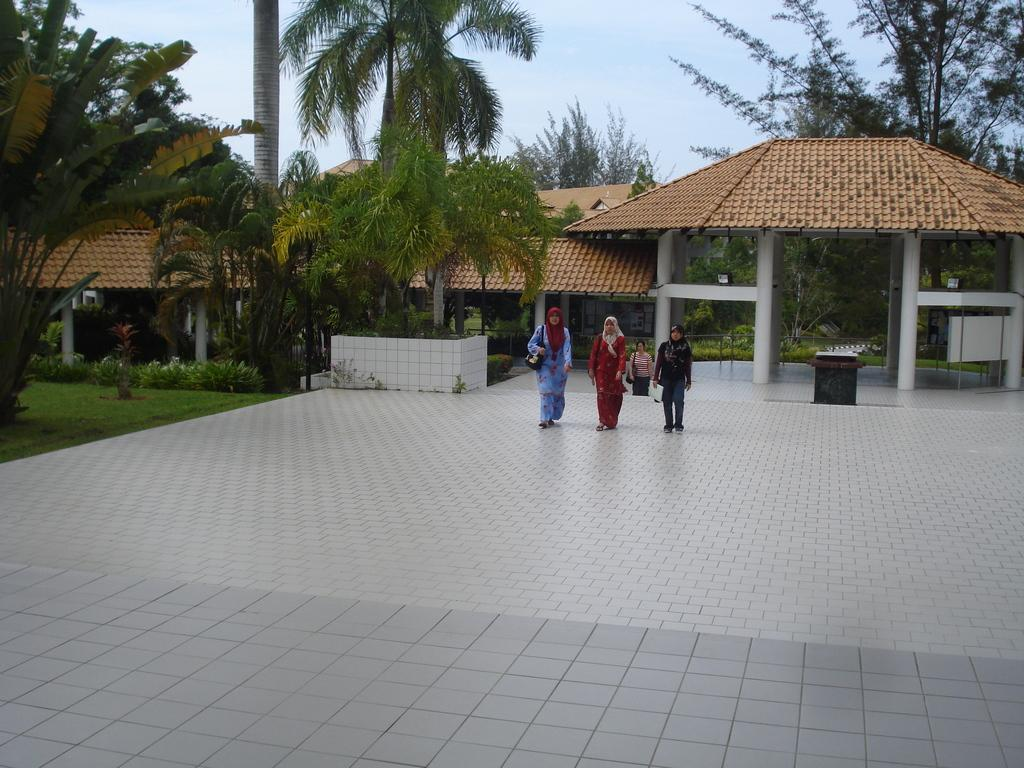How many people are present in the image? There are people in the image, but the exact number is not specified. What are the people wearing that resemble bags? Some of the people are wearing bags in the image. What type of vegetation can be seen in the image? There are plants and trees in the image. What type of structures are visible in the image? There are houses in the image. What is visible at the top of the image? The sky is visible in the image. How many minutes does it take for the pigs to cross the road in the image? There are no pigs present in the image, so it is not possible to determine how long it would take for them to cross the road. 